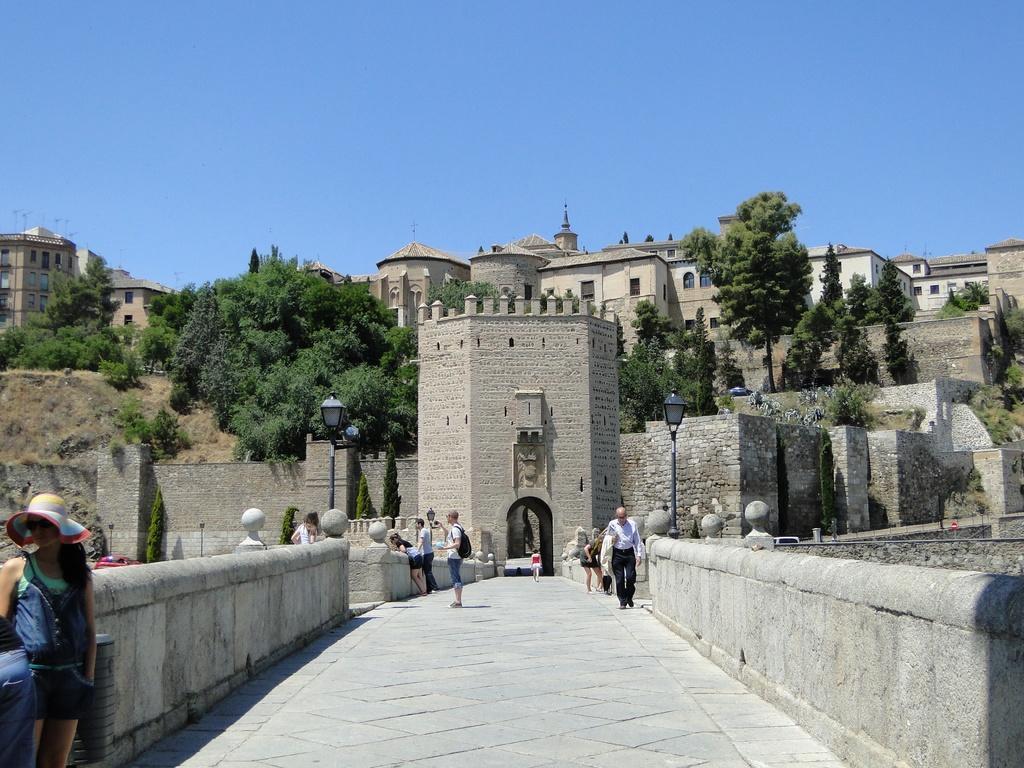In one or two sentences, can you explain what this image depicts? This picture is clicked outside. In the center we can see the group of people. In the background we can see the buildings, trees, lights attached to the poles and the sky. 